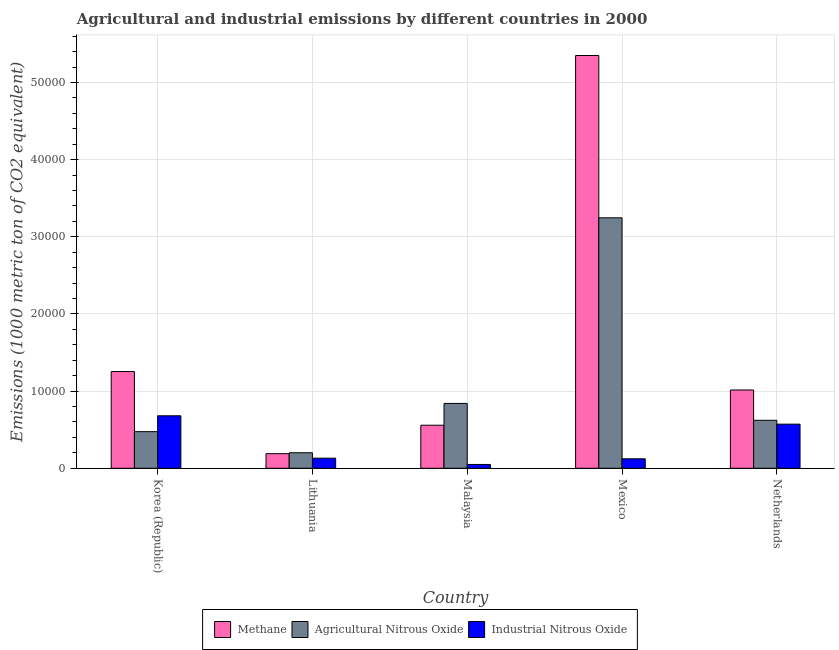How many different coloured bars are there?
Give a very brief answer. 3. Are the number of bars per tick equal to the number of legend labels?
Your answer should be very brief. Yes. Are the number of bars on each tick of the X-axis equal?
Your response must be concise. Yes. How many bars are there on the 5th tick from the left?
Keep it short and to the point. 3. How many bars are there on the 3rd tick from the right?
Offer a terse response. 3. In how many cases, is the number of bars for a given country not equal to the number of legend labels?
Your response must be concise. 0. What is the amount of industrial nitrous oxide emissions in Malaysia?
Your response must be concise. 493.8. Across all countries, what is the maximum amount of industrial nitrous oxide emissions?
Your answer should be compact. 6803. Across all countries, what is the minimum amount of industrial nitrous oxide emissions?
Offer a terse response. 493.8. In which country was the amount of industrial nitrous oxide emissions minimum?
Keep it short and to the point. Malaysia. What is the total amount of methane emissions in the graph?
Ensure brevity in your answer.  8.37e+04. What is the difference between the amount of industrial nitrous oxide emissions in Mexico and that in Netherlands?
Give a very brief answer. -4491.9. What is the difference between the amount of agricultural nitrous oxide emissions in Mexico and the amount of industrial nitrous oxide emissions in Netherlands?
Provide a short and direct response. 2.67e+04. What is the average amount of methane emissions per country?
Your answer should be compact. 1.67e+04. What is the difference between the amount of industrial nitrous oxide emissions and amount of methane emissions in Korea (Republic)?
Offer a very short reply. -5736.1. What is the ratio of the amount of industrial nitrous oxide emissions in Lithuania to that in Malaysia?
Offer a terse response. 2.65. Is the amount of agricultural nitrous oxide emissions in Malaysia less than that in Netherlands?
Your answer should be compact. No. What is the difference between the highest and the second highest amount of methane emissions?
Give a very brief answer. 4.10e+04. What is the difference between the highest and the lowest amount of industrial nitrous oxide emissions?
Keep it short and to the point. 6309.2. What does the 3rd bar from the left in Lithuania represents?
Provide a short and direct response. Industrial Nitrous Oxide. What does the 2nd bar from the right in Lithuania represents?
Provide a short and direct response. Agricultural Nitrous Oxide. Is it the case that in every country, the sum of the amount of methane emissions and amount of agricultural nitrous oxide emissions is greater than the amount of industrial nitrous oxide emissions?
Provide a succinct answer. Yes. How many countries are there in the graph?
Offer a terse response. 5. What is the difference between two consecutive major ticks on the Y-axis?
Provide a succinct answer. 10000. Are the values on the major ticks of Y-axis written in scientific E-notation?
Keep it short and to the point. No. Does the graph contain grids?
Keep it short and to the point. Yes. How many legend labels are there?
Ensure brevity in your answer.  3. How are the legend labels stacked?
Provide a succinct answer. Horizontal. What is the title of the graph?
Provide a succinct answer. Agricultural and industrial emissions by different countries in 2000. Does "Labor Market" appear as one of the legend labels in the graph?
Make the answer very short. No. What is the label or title of the Y-axis?
Provide a short and direct response. Emissions (1000 metric ton of CO2 equivalent). What is the Emissions (1000 metric ton of CO2 equivalent) of Methane in Korea (Republic)?
Make the answer very short. 1.25e+04. What is the Emissions (1000 metric ton of CO2 equivalent) of Agricultural Nitrous Oxide in Korea (Republic)?
Provide a succinct answer. 4746.8. What is the Emissions (1000 metric ton of CO2 equivalent) of Industrial Nitrous Oxide in Korea (Republic)?
Your answer should be very brief. 6803. What is the Emissions (1000 metric ton of CO2 equivalent) in Methane in Lithuania?
Keep it short and to the point. 1892.9. What is the Emissions (1000 metric ton of CO2 equivalent) in Agricultural Nitrous Oxide in Lithuania?
Provide a succinct answer. 2010.8. What is the Emissions (1000 metric ton of CO2 equivalent) of Industrial Nitrous Oxide in Lithuania?
Keep it short and to the point. 1308.5. What is the Emissions (1000 metric ton of CO2 equivalent) in Methane in Malaysia?
Your answer should be very brief. 5579.2. What is the Emissions (1000 metric ton of CO2 equivalent) in Agricultural Nitrous Oxide in Malaysia?
Your response must be concise. 8403.2. What is the Emissions (1000 metric ton of CO2 equivalent) in Industrial Nitrous Oxide in Malaysia?
Provide a succinct answer. 493.8. What is the Emissions (1000 metric ton of CO2 equivalent) of Methane in Mexico?
Keep it short and to the point. 5.35e+04. What is the Emissions (1000 metric ton of CO2 equivalent) of Agricultural Nitrous Oxide in Mexico?
Provide a succinct answer. 3.25e+04. What is the Emissions (1000 metric ton of CO2 equivalent) of Industrial Nitrous Oxide in Mexico?
Offer a terse response. 1227.6. What is the Emissions (1000 metric ton of CO2 equivalent) of Methane in Netherlands?
Your answer should be compact. 1.01e+04. What is the Emissions (1000 metric ton of CO2 equivalent) in Agricultural Nitrous Oxide in Netherlands?
Provide a succinct answer. 6219.5. What is the Emissions (1000 metric ton of CO2 equivalent) of Industrial Nitrous Oxide in Netherlands?
Ensure brevity in your answer.  5719.5. Across all countries, what is the maximum Emissions (1000 metric ton of CO2 equivalent) in Methane?
Offer a terse response. 5.35e+04. Across all countries, what is the maximum Emissions (1000 metric ton of CO2 equivalent) in Agricultural Nitrous Oxide?
Your response must be concise. 3.25e+04. Across all countries, what is the maximum Emissions (1000 metric ton of CO2 equivalent) of Industrial Nitrous Oxide?
Provide a short and direct response. 6803. Across all countries, what is the minimum Emissions (1000 metric ton of CO2 equivalent) of Methane?
Your answer should be very brief. 1892.9. Across all countries, what is the minimum Emissions (1000 metric ton of CO2 equivalent) of Agricultural Nitrous Oxide?
Provide a succinct answer. 2010.8. Across all countries, what is the minimum Emissions (1000 metric ton of CO2 equivalent) in Industrial Nitrous Oxide?
Give a very brief answer. 493.8. What is the total Emissions (1000 metric ton of CO2 equivalent) of Methane in the graph?
Provide a succinct answer. 8.37e+04. What is the total Emissions (1000 metric ton of CO2 equivalent) in Agricultural Nitrous Oxide in the graph?
Keep it short and to the point. 5.38e+04. What is the total Emissions (1000 metric ton of CO2 equivalent) in Industrial Nitrous Oxide in the graph?
Your answer should be compact. 1.56e+04. What is the difference between the Emissions (1000 metric ton of CO2 equivalent) in Methane in Korea (Republic) and that in Lithuania?
Your response must be concise. 1.06e+04. What is the difference between the Emissions (1000 metric ton of CO2 equivalent) of Agricultural Nitrous Oxide in Korea (Republic) and that in Lithuania?
Give a very brief answer. 2736. What is the difference between the Emissions (1000 metric ton of CO2 equivalent) of Industrial Nitrous Oxide in Korea (Republic) and that in Lithuania?
Provide a short and direct response. 5494.5. What is the difference between the Emissions (1000 metric ton of CO2 equivalent) in Methane in Korea (Republic) and that in Malaysia?
Offer a terse response. 6959.9. What is the difference between the Emissions (1000 metric ton of CO2 equivalent) in Agricultural Nitrous Oxide in Korea (Republic) and that in Malaysia?
Make the answer very short. -3656.4. What is the difference between the Emissions (1000 metric ton of CO2 equivalent) of Industrial Nitrous Oxide in Korea (Republic) and that in Malaysia?
Ensure brevity in your answer.  6309.2. What is the difference between the Emissions (1000 metric ton of CO2 equivalent) of Methane in Korea (Republic) and that in Mexico?
Provide a short and direct response. -4.10e+04. What is the difference between the Emissions (1000 metric ton of CO2 equivalent) of Agricultural Nitrous Oxide in Korea (Republic) and that in Mexico?
Keep it short and to the point. -2.77e+04. What is the difference between the Emissions (1000 metric ton of CO2 equivalent) in Industrial Nitrous Oxide in Korea (Republic) and that in Mexico?
Ensure brevity in your answer.  5575.4. What is the difference between the Emissions (1000 metric ton of CO2 equivalent) of Methane in Korea (Republic) and that in Netherlands?
Offer a very short reply. 2394.3. What is the difference between the Emissions (1000 metric ton of CO2 equivalent) in Agricultural Nitrous Oxide in Korea (Republic) and that in Netherlands?
Your response must be concise. -1472.7. What is the difference between the Emissions (1000 metric ton of CO2 equivalent) in Industrial Nitrous Oxide in Korea (Republic) and that in Netherlands?
Offer a very short reply. 1083.5. What is the difference between the Emissions (1000 metric ton of CO2 equivalent) of Methane in Lithuania and that in Malaysia?
Give a very brief answer. -3686.3. What is the difference between the Emissions (1000 metric ton of CO2 equivalent) of Agricultural Nitrous Oxide in Lithuania and that in Malaysia?
Keep it short and to the point. -6392.4. What is the difference between the Emissions (1000 metric ton of CO2 equivalent) in Industrial Nitrous Oxide in Lithuania and that in Malaysia?
Make the answer very short. 814.7. What is the difference between the Emissions (1000 metric ton of CO2 equivalent) of Methane in Lithuania and that in Mexico?
Ensure brevity in your answer.  -5.16e+04. What is the difference between the Emissions (1000 metric ton of CO2 equivalent) of Agricultural Nitrous Oxide in Lithuania and that in Mexico?
Keep it short and to the point. -3.05e+04. What is the difference between the Emissions (1000 metric ton of CO2 equivalent) of Industrial Nitrous Oxide in Lithuania and that in Mexico?
Make the answer very short. 80.9. What is the difference between the Emissions (1000 metric ton of CO2 equivalent) in Methane in Lithuania and that in Netherlands?
Provide a succinct answer. -8251.9. What is the difference between the Emissions (1000 metric ton of CO2 equivalent) of Agricultural Nitrous Oxide in Lithuania and that in Netherlands?
Ensure brevity in your answer.  -4208.7. What is the difference between the Emissions (1000 metric ton of CO2 equivalent) of Industrial Nitrous Oxide in Lithuania and that in Netherlands?
Give a very brief answer. -4411. What is the difference between the Emissions (1000 metric ton of CO2 equivalent) in Methane in Malaysia and that in Mexico?
Your answer should be compact. -4.79e+04. What is the difference between the Emissions (1000 metric ton of CO2 equivalent) of Agricultural Nitrous Oxide in Malaysia and that in Mexico?
Your answer should be very brief. -2.41e+04. What is the difference between the Emissions (1000 metric ton of CO2 equivalent) of Industrial Nitrous Oxide in Malaysia and that in Mexico?
Ensure brevity in your answer.  -733.8. What is the difference between the Emissions (1000 metric ton of CO2 equivalent) of Methane in Malaysia and that in Netherlands?
Offer a very short reply. -4565.6. What is the difference between the Emissions (1000 metric ton of CO2 equivalent) of Agricultural Nitrous Oxide in Malaysia and that in Netherlands?
Ensure brevity in your answer.  2183.7. What is the difference between the Emissions (1000 metric ton of CO2 equivalent) in Industrial Nitrous Oxide in Malaysia and that in Netherlands?
Offer a terse response. -5225.7. What is the difference between the Emissions (1000 metric ton of CO2 equivalent) in Methane in Mexico and that in Netherlands?
Your response must be concise. 4.34e+04. What is the difference between the Emissions (1000 metric ton of CO2 equivalent) of Agricultural Nitrous Oxide in Mexico and that in Netherlands?
Your response must be concise. 2.62e+04. What is the difference between the Emissions (1000 metric ton of CO2 equivalent) of Industrial Nitrous Oxide in Mexico and that in Netherlands?
Ensure brevity in your answer.  -4491.9. What is the difference between the Emissions (1000 metric ton of CO2 equivalent) in Methane in Korea (Republic) and the Emissions (1000 metric ton of CO2 equivalent) in Agricultural Nitrous Oxide in Lithuania?
Ensure brevity in your answer.  1.05e+04. What is the difference between the Emissions (1000 metric ton of CO2 equivalent) in Methane in Korea (Republic) and the Emissions (1000 metric ton of CO2 equivalent) in Industrial Nitrous Oxide in Lithuania?
Make the answer very short. 1.12e+04. What is the difference between the Emissions (1000 metric ton of CO2 equivalent) of Agricultural Nitrous Oxide in Korea (Republic) and the Emissions (1000 metric ton of CO2 equivalent) of Industrial Nitrous Oxide in Lithuania?
Your response must be concise. 3438.3. What is the difference between the Emissions (1000 metric ton of CO2 equivalent) of Methane in Korea (Republic) and the Emissions (1000 metric ton of CO2 equivalent) of Agricultural Nitrous Oxide in Malaysia?
Offer a terse response. 4135.9. What is the difference between the Emissions (1000 metric ton of CO2 equivalent) of Methane in Korea (Republic) and the Emissions (1000 metric ton of CO2 equivalent) of Industrial Nitrous Oxide in Malaysia?
Your response must be concise. 1.20e+04. What is the difference between the Emissions (1000 metric ton of CO2 equivalent) in Agricultural Nitrous Oxide in Korea (Republic) and the Emissions (1000 metric ton of CO2 equivalent) in Industrial Nitrous Oxide in Malaysia?
Offer a very short reply. 4253. What is the difference between the Emissions (1000 metric ton of CO2 equivalent) of Methane in Korea (Republic) and the Emissions (1000 metric ton of CO2 equivalent) of Agricultural Nitrous Oxide in Mexico?
Offer a very short reply. -1.99e+04. What is the difference between the Emissions (1000 metric ton of CO2 equivalent) in Methane in Korea (Republic) and the Emissions (1000 metric ton of CO2 equivalent) in Industrial Nitrous Oxide in Mexico?
Your answer should be compact. 1.13e+04. What is the difference between the Emissions (1000 metric ton of CO2 equivalent) in Agricultural Nitrous Oxide in Korea (Republic) and the Emissions (1000 metric ton of CO2 equivalent) in Industrial Nitrous Oxide in Mexico?
Provide a short and direct response. 3519.2. What is the difference between the Emissions (1000 metric ton of CO2 equivalent) of Methane in Korea (Republic) and the Emissions (1000 metric ton of CO2 equivalent) of Agricultural Nitrous Oxide in Netherlands?
Provide a succinct answer. 6319.6. What is the difference between the Emissions (1000 metric ton of CO2 equivalent) of Methane in Korea (Republic) and the Emissions (1000 metric ton of CO2 equivalent) of Industrial Nitrous Oxide in Netherlands?
Give a very brief answer. 6819.6. What is the difference between the Emissions (1000 metric ton of CO2 equivalent) of Agricultural Nitrous Oxide in Korea (Republic) and the Emissions (1000 metric ton of CO2 equivalent) of Industrial Nitrous Oxide in Netherlands?
Give a very brief answer. -972.7. What is the difference between the Emissions (1000 metric ton of CO2 equivalent) in Methane in Lithuania and the Emissions (1000 metric ton of CO2 equivalent) in Agricultural Nitrous Oxide in Malaysia?
Offer a terse response. -6510.3. What is the difference between the Emissions (1000 metric ton of CO2 equivalent) of Methane in Lithuania and the Emissions (1000 metric ton of CO2 equivalent) of Industrial Nitrous Oxide in Malaysia?
Make the answer very short. 1399.1. What is the difference between the Emissions (1000 metric ton of CO2 equivalent) in Agricultural Nitrous Oxide in Lithuania and the Emissions (1000 metric ton of CO2 equivalent) in Industrial Nitrous Oxide in Malaysia?
Provide a short and direct response. 1517. What is the difference between the Emissions (1000 metric ton of CO2 equivalent) of Methane in Lithuania and the Emissions (1000 metric ton of CO2 equivalent) of Agricultural Nitrous Oxide in Mexico?
Make the answer very short. -3.06e+04. What is the difference between the Emissions (1000 metric ton of CO2 equivalent) of Methane in Lithuania and the Emissions (1000 metric ton of CO2 equivalent) of Industrial Nitrous Oxide in Mexico?
Your answer should be compact. 665.3. What is the difference between the Emissions (1000 metric ton of CO2 equivalent) in Agricultural Nitrous Oxide in Lithuania and the Emissions (1000 metric ton of CO2 equivalent) in Industrial Nitrous Oxide in Mexico?
Provide a short and direct response. 783.2. What is the difference between the Emissions (1000 metric ton of CO2 equivalent) of Methane in Lithuania and the Emissions (1000 metric ton of CO2 equivalent) of Agricultural Nitrous Oxide in Netherlands?
Make the answer very short. -4326.6. What is the difference between the Emissions (1000 metric ton of CO2 equivalent) of Methane in Lithuania and the Emissions (1000 metric ton of CO2 equivalent) of Industrial Nitrous Oxide in Netherlands?
Your response must be concise. -3826.6. What is the difference between the Emissions (1000 metric ton of CO2 equivalent) of Agricultural Nitrous Oxide in Lithuania and the Emissions (1000 metric ton of CO2 equivalent) of Industrial Nitrous Oxide in Netherlands?
Ensure brevity in your answer.  -3708.7. What is the difference between the Emissions (1000 metric ton of CO2 equivalent) of Methane in Malaysia and the Emissions (1000 metric ton of CO2 equivalent) of Agricultural Nitrous Oxide in Mexico?
Your answer should be compact. -2.69e+04. What is the difference between the Emissions (1000 metric ton of CO2 equivalent) in Methane in Malaysia and the Emissions (1000 metric ton of CO2 equivalent) in Industrial Nitrous Oxide in Mexico?
Keep it short and to the point. 4351.6. What is the difference between the Emissions (1000 metric ton of CO2 equivalent) of Agricultural Nitrous Oxide in Malaysia and the Emissions (1000 metric ton of CO2 equivalent) of Industrial Nitrous Oxide in Mexico?
Offer a terse response. 7175.6. What is the difference between the Emissions (1000 metric ton of CO2 equivalent) in Methane in Malaysia and the Emissions (1000 metric ton of CO2 equivalent) in Agricultural Nitrous Oxide in Netherlands?
Your answer should be very brief. -640.3. What is the difference between the Emissions (1000 metric ton of CO2 equivalent) in Methane in Malaysia and the Emissions (1000 metric ton of CO2 equivalent) in Industrial Nitrous Oxide in Netherlands?
Ensure brevity in your answer.  -140.3. What is the difference between the Emissions (1000 metric ton of CO2 equivalent) of Agricultural Nitrous Oxide in Malaysia and the Emissions (1000 metric ton of CO2 equivalent) of Industrial Nitrous Oxide in Netherlands?
Keep it short and to the point. 2683.7. What is the difference between the Emissions (1000 metric ton of CO2 equivalent) of Methane in Mexico and the Emissions (1000 metric ton of CO2 equivalent) of Agricultural Nitrous Oxide in Netherlands?
Provide a succinct answer. 4.73e+04. What is the difference between the Emissions (1000 metric ton of CO2 equivalent) of Methane in Mexico and the Emissions (1000 metric ton of CO2 equivalent) of Industrial Nitrous Oxide in Netherlands?
Make the answer very short. 4.78e+04. What is the difference between the Emissions (1000 metric ton of CO2 equivalent) in Agricultural Nitrous Oxide in Mexico and the Emissions (1000 metric ton of CO2 equivalent) in Industrial Nitrous Oxide in Netherlands?
Offer a very short reply. 2.67e+04. What is the average Emissions (1000 metric ton of CO2 equivalent) of Methane per country?
Your answer should be very brief. 1.67e+04. What is the average Emissions (1000 metric ton of CO2 equivalent) of Agricultural Nitrous Oxide per country?
Keep it short and to the point. 1.08e+04. What is the average Emissions (1000 metric ton of CO2 equivalent) of Industrial Nitrous Oxide per country?
Give a very brief answer. 3110.48. What is the difference between the Emissions (1000 metric ton of CO2 equivalent) of Methane and Emissions (1000 metric ton of CO2 equivalent) of Agricultural Nitrous Oxide in Korea (Republic)?
Your answer should be very brief. 7792.3. What is the difference between the Emissions (1000 metric ton of CO2 equivalent) of Methane and Emissions (1000 metric ton of CO2 equivalent) of Industrial Nitrous Oxide in Korea (Republic)?
Keep it short and to the point. 5736.1. What is the difference between the Emissions (1000 metric ton of CO2 equivalent) in Agricultural Nitrous Oxide and Emissions (1000 metric ton of CO2 equivalent) in Industrial Nitrous Oxide in Korea (Republic)?
Offer a very short reply. -2056.2. What is the difference between the Emissions (1000 metric ton of CO2 equivalent) in Methane and Emissions (1000 metric ton of CO2 equivalent) in Agricultural Nitrous Oxide in Lithuania?
Your answer should be compact. -117.9. What is the difference between the Emissions (1000 metric ton of CO2 equivalent) of Methane and Emissions (1000 metric ton of CO2 equivalent) of Industrial Nitrous Oxide in Lithuania?
Your response must be concise. 584.4. What is the difference between the Emissions (1000 metric ton of CO2 equivalent) of Agricultural Nitrous Oxide and Emissions (1000 metric ton of CO2 equivalent) of Industrial Nitrous Oxide in Lithuania?
Offer a terse response. 702.3. What is the difference between the Emissions (1000 metric ton of CO2 equivalent) in Methane and Emissions (1000 metric ton of CO2 equivalent) in Agricultural Nitrous Oxide in Malaysia?
Your answer should be compact. -2824. What is the difference between the Emissions (1000 metric ton of CO2 equivalent) in Methane and Emissions (1000 metric ton of CO2 equivalent) in Industrial Nitrous Oxide in Malaysia?
Ensure brevity in your answer.  5085.4. What is the difference between the Emissions (1000 metric ton of CO2 equivalent) of Agricultural Nitrous Oxide and Emissions (1000 metric ton of CO2 equivalent) of Industrial Nitrous Oxide in Malaysia?
Your answer should be very brief. 7909.4. What is the difference between the Emissions (1000 metric ton of CO2 equivalent) in Methane and Emissions (1000 metric ton of CO2 equivalent) in Agricultural Nitrous Oxide in Mexico?
Your answer should be very brief. 2.10e+04. What is the difference between the Emissions (1000 metric ton of CO2 equivalent) in Methane and Emissions (1000 metric ton of CO2 equivalent) in Industrial Nitrous Oxide in Mexico?
Keep it short and to the point. 5.23e+04. What is the difference between the Emissions (1000 metric ton of CO2 equivalent) of Agricultural Nitrous Oxide and Emissions (1000 metric ton of CO2 equivalent) of Industrial Nitrous Oxide in Mexico?
Offer a very short reply. 3.12e+04. What is the difference between the Emissions (1000 metric ton of CO2 equivalent) of Methane and Emissions (1000 metric ton of CO2 equivalent) of Agricultural Nitrous Oxide in Netherlands?
Provide a short and direct response. 3925.3. What is the difference between the Emissions (1000 metric ton of CO2 equivalent) of Methane and Emissions (1000 metric ton of CO2 equivalent) of Industrial Nitrous Oxide in Netherlands?
Your answer should be very brief. 4425.3. What is the ratio of the Emissions (1000 metric ton of CO2 equivalent) of Methane in Korea (Republic) to that in Lithuania?
Ensure brevity in your answer.  6.62. What is the ratio of the Emissions (1000 metric ton of CO2 equivalent) of Agricultural Nitrous Oxide in Korea (Republic) to that in Lithuania?
Offer a terse response. 2.36. What is the ratio of the Emissions (1000 metric ton of CO2 equivalent) of Industrial Nitrous Oxide in Korea (Republic) to that in Lithuania?
Keep it short and to the point. 5.2. What is the ratio of the Emissions (1000 metric ton of CO2 equivalent) of Methane in Korea (Republic) to that in Malaysia?
Keep it short and to the point. 2.25. What is the ratio of the Emissions (1000 metric ton of CO2 equivalent) in Agricultural Nitrous Oxide in Korea (Republic) to that in Malaysia?
Offer a terse response. 0.56. What is the ratio of the Emissions (1000 metric ton of CO2 equivalent) of Industrial Nitrous Oxide in Korea (Republic) to that in Malaysia?
Your response must be concise. 13.78. What is the ratio of the Emissions (1000 metric ton of CO2 equivalent) in Methane in Korea (Republic) to that in Mexico?
Give a very brief answer. 0.23. What is the ratio of the Emissions (1000 metric ton of CO2 equivalent) in Agricultural Nitrous Oxide in Korea (Republic) to that in Mexico?
Keep it short and to the point. 0.15. What is the ratio of the Emissions (1000 metric ton of CO2 equivalent) in Industrial Nitrous Oxide in Korea (Republic) to that in Mexico?
Offer a terse response. 5.54. What is the ratio of the Emissions (1000 metric ton of CO2 equivalent) in Methane in Korea (Republic) to that in Netherlands?
Keep it short and to the point. 1.24. What is the ratio of the Emissions (1000 metric ton of CO2 equivalent) in Agricultural Nitrous Oxide in Korea (Republic) to that in Netherlands?
Offer a very short reply. 0.76. What is the ratio of the Emissions (1000 metric ton of CO2 equivalent) of Industrial Nitrous Oxide in Korea (Republic) to that in Netherlands?
Keep it short and to the point. 1.19. What is the ratio of the Emissions (1000 metric ton of CO2 equivalent) in Methane in Lithuania to that in Malaysia?
Give a very brief answer. 0.34. What is the ratio of the Emissions (1000 metric ton of CO2 equivalent) of Agricultural Nitrous Oxide in Lithuania to that in Malaysia?
Provide a succinct answer. 0.24. What is the ratio of the Emissions (1000 metric ton of CO2 equivalent) of Industrial Nitrous Oxide in Lithuania to that in Malaysia?
Provide a short and direct response. 2.65. What is the ratio of the Emissions (1000 metric ton of CO2 equivalent) of Methane in Lithuania to that in Mexico?
Offer a very short reply. 0.04. What is the ratio of the Emissions (1000 metric ton of CO2 equivalent) in Agricultural Nitrous Oxide in Lithuania to that in Mexico?
Your answer should be compact. 0.06. What is the ratio of the Emissions (1000 metric ton of CO2 equivalent) of Industrial Nitrous Oxide in Lithuania to that in Mexico?
Provide a short and direct response. 1.07. What is the ratio of the Emissions (1000 metric ton of CO2 equivalent) in Methane in Lithuania to that in Netherlands?
Your response must be concise. 0.19. What is the ratio of the Emissions (1000 metric ton of CO2 equivalent) of Agricultural Nitrous Oxide in Lithuania to that in Netherlands?
Offer a very short reply. 0.32. What is the ratio of the Emissions (1000 metric ton of CO2 equivalent) of Industrial Nitrous Oxide in Lithuania to that in Netherlands?
Provide a short and direct response. 0.23. What is the ratio of the Emissions (1000 metric ton of CO2 equivalent) of Methane in Malaysia to that in Mexico?
Ensure brevity in your answer.  0.1. What is the ratio of the Emissions (1000 metric ton of CO2 equivalent) in Agricultural Nitrous Oxide in Malaysia to that in Mexico?
Your answer should be very brief. 0.26. What is the ratio of the Emissions (1000 metric ton of CO2 equivalent) in Industrial Nitrous Oxide in Malaysia to that in Mexico?
Your answer should be compact. 0.4. What is the ratio of the Emissions (1000 metric ton of CO2 equivalent) in Methane in Malaysia to that in Netherlands?
Give a very brief answer. 0.55. What is the ratio of the Emissions (1000 metric ton of CO2 equivalent) of Agricultural Nitrous Oxide in Malaysia to that in Netherlands?
Provide a succinct answer. 1.35. What is the ratio of the Emissions (1000 metric ton of CO2 equivalent) of Industrial Nitrous Oxide in Malaysia to that in Netherlands?
Keep it short and to the point. 0.09. What is the ratio of the Emissions (1000 metric ton of CO2 equivalent) of Methane in Mexico to that in Netherlands?
Make the answer very short. 5.27. What is the ratio of the Emissions (1000 metric ton of CO2 equivalent) of Agricultural Nitrous Oxide in Mexico to that in Netherlands?
Give a very brief answer. 5.22. What is the ratio of the Emissions (1000 metric ton of CO2 equivalent) of Industrial Nitrous Oxide in Mexico to that in Netherlands?
Your response must be concise. 0.21. What is the difference between the highest and the second highest Emissions (1000 metric ton of CO2 equivalent) in Methane?
Ensure brevity in your answer.  4.10e+04. What is the difference between the highest and the second highest Emissions (1000 metric ton of CO2 equivalent) in Agricultural Nitrous Oxide?
Make the answer very short. 2.41e+04. What is the difference between the highest and the second highest Emissions (1000 metric ton of CO2 equivalent) in Industrial Nitrous Oxide?
Provide a succinct answer. 1083.5. What is the difference between the highest and the lowest Emissions (1000 metric ton of CO2 equivalent) in Methane?
Provide a succinct answer. 5.16e+04. What is the difference between the highest and the lowest Emissions (1000 metric ton of CO2 equivalent) in Agricultural Nitrous Oxide?
Your answer should be very brief. 3.05e+04. What is the difference between the highest and the lowest Emissions (1000 metric ton of CO2 equivalent) of Industrial Nitrous Oxide?
Offer a very short reply. 6309.2. 